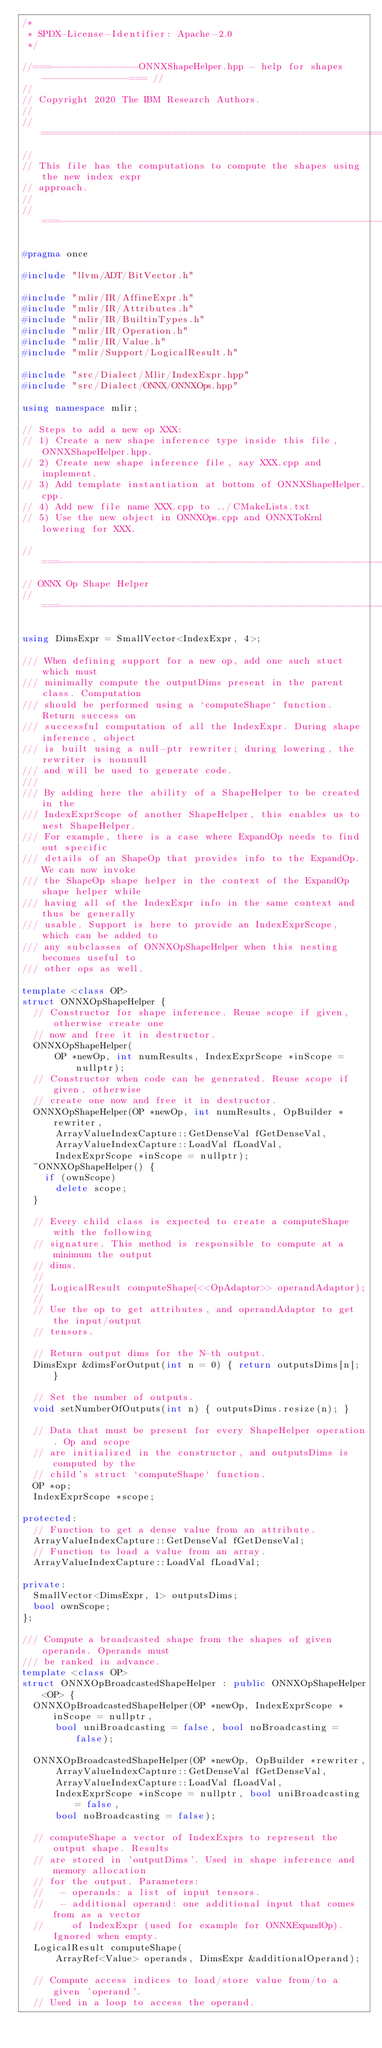<code> <loc_0><loc_0><loc_500><loc_500><_C++_>/*
 * SPDX-License-Identifier: Apache-2.0
 */

//===----------------ONNXShapeHelper.hpp - help for shapes----------------=== //
//
// Copyright 2020 The IBM Research Authors.
//
// =============================================================================
//
// This file has the computations to compute the shapes using the new index expr
// approach.
//
//===----------------------------------------------------------------------===//

#pragma once

#include "llvm/ADT/BitVector.h"

#include "mlir/IR/AffineExpr.h"
#include "mlir/IR/Attributes.h"
#include "mlir/IR/BuiltinTypes.h"
#include "mlir/IR/Operation.h"
#include "mlir/IR/Value.h"
#include "mlir/Support/LogicalResult.h"

#include "src/Dialect/Mlir/IndexExpr.hpp"
#include "src/Dialect/ONNX/ONNXOps.hpp"

using namespace mlir;

// Steps to add a new op XXX:
// 1) Create a new shape inference type inside this file, ONNXShapeHelper.hpp.
// 2) Create new shape inference file, say XXX.cpp and implement.
// 3) Add template instantiation at bottom of ONNXShapeHelper.cpp.
// 4) Add new file name XXX.cpp to ../CMakeLists.txt
// 5) Use the new object in ONNXOps.cpp and ONNXToKrnl lowering for XXX.

//===----------------------------------------------------------------------===//
// ONNX Op Shape Helper
//===----------------------------------------------------------------------===//

using DimsExpr = SmallVector<IndexExpr, 4>;

/// When defining support for a new op, add one such stuct which must
/// minimally compute the outputDims present in the parent class. Computation
/// should be performed using a `computeShape` function. Return success on
/// successful computation of all the IndexExpr. During shape inference, object
/// is built using a null-ptr rewriter; during lowering, the rewriter is nonnull
/// and will be used to generate code.
///
/// By adding here the ability of a ShapeHelper to be created in the
/// IndexExprScope of another ShapeHelper, this enables us to nest ShapeHelper.
/// For example, there is a case where ExpandOp needs to find out specific
/// details of an ShapeOp that provides info to the ExpandOp. We can now invoke
/// the ShapeOp shape helper in the context of the ExpandOp shape helper while
/// having all of the IndexExpr info in the same context and thus be generally
/// usable. Support is here to provide an IndexExprScope, which can be added to
/// any subclasses of ONNXOpShapeHelper when this nesting becomes useful to
/// other ops as well.

template <class OP>
struct ONNXOpShapeHelper {
  // Constructor for shape inference. Reuse scope if given, otherwise create one
  // now and free it in destructor.
  ONNXOpShapeHelper(
      OP *newOp, int numResults, IndexExprScope *inScope = nullptr);
  // Constructor when code can be generated. Reuse scope if given, otherwise
  // create one now and free it in destructor.
  ONNXOpShapeHelper(OP *newOp, int numResults, OpBuilder *rewriter,
      ArrayValueIndexCapture::GetDenseVal fGetDenseVal,
      ArrayValueIndexCapture::LoadVal fLoadVal,
      IndexExprScope *inScope = nullptr);
  ~ONNXOpShapeHelper() {
    if (ownScope)
      delete scope;
  }

  // Every child class is expected to create a computeShape with the following
  // signature. This method is responsible to compute at a minimum the output
  // dims.
  //
  // LogicalResult computeShape(<<OpAdaptor>> operandAdaptor);
  //
  // Use the op to get attributes, and operandAdaptor to get the input/output
  // tensors.

  // Return output dims for the N-th output.
  DimsExpr &dimsForOutput(int n = 0) { return outputsDims[n]; }

  // Set the number of outputs.
  void setNumberOfOutputs(int n) { outputsDims.resize(n); }

  // Data that must be present for every ShapeHelper operation. Op and scope
  // are initialized in the constructor, and outputsDims is computed by the
  // child's struct `computeShape` function.
  OP *op;
  IndexExprScope *scope;

protected:
  // Function to get a dense value from an attribute.
  ArrayValueIndexCapture::GetDenseVal fGetDenseVal;
  // Function to load a value from an array.
  ArrayValueIndexCapture::LoadVal fLoadVal;

private:
  SmallVector<DimsExpr, 1> outputsDims;
  bool ownScope;
};

/// Compute a broadcasted shape from the shapes of given operands. Operands must
/// be ranked in advance.
template <class OP>
struct ONNXOpBroadcastedShapeHelper : public ONNXOpShapeHelper<OP> {
  ONNXOpBroadcastedShapeHelper(OP *newOp, IndexExprScope *inScope = nullptr,
      bool uniBroadcasting = false, bool noBroadcasting = false);

  ONNXOpBroadcastedShapeHelper(OP *newOp, OpBuilder *rewriter,
      ArrayValueIndexCapture::GetDenseVal fGetDenseVal,
      ArrayValueIndexCapture::LoadVal fLoadVal,
      IndexExprScope *inScope = nullptr, bool uniBroadcasting = false,
      bool noBroadcasting = false);

  // computeShape a vector of IndexExprs to represent the output shape. Results
  // are stored in 'outputDims'. Used in shape inference and memory allocation
  // for the output. Parameters:
  //   - operands: a list of input tensors.
  //   - additional operand: one additional input that comes from as a vector
  //     of IndexExpr (used for example for ONNXExpandOp). Ignored when empty.
  LogicalResult computeShape(
      ArrayRef<Value> operands, DimsExpr &additionalOperand);

  // Compute access indices to load/store value from/to a given 'operand'.
  // Used in a loop to access the operand.</code> 